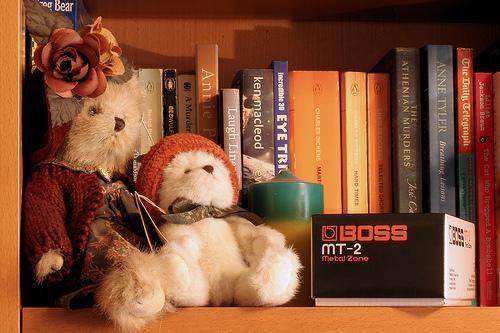How many books are visible?
Give a very brief answer. 15. 